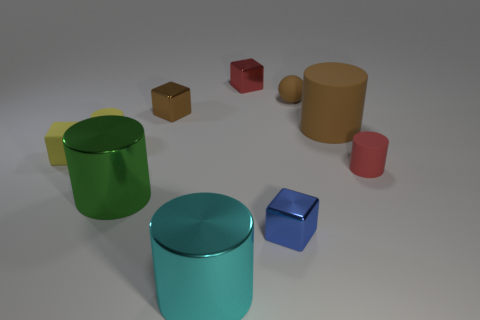What material is the large object that is the same color as the ball?
Your response must be concise. Rubber. There is a tiny yellow object that is the same shape as the big brown matte object; what material is it?
Your answer should be very brief. Rubber. What number of cylinders have the same size as the green thing?
Ensure brevity in your answer.  2. What is the color of the tiny ball that is the same material as the yellow block?
Offer a very short reply. Brown. Are there fewer tiny objects than tiny purple cylinders?
Your answer should be very brief. No. What number of cyan things are either small rubber balls or big rubber cylinders?
Offer a very short reply. 0. How many rubber objects are both on the right side of the ball and to the left of the red rubber thing?
Provide a short and direct response. 1. Are the brown ball and the big cyan cylinder made of the same material?
Offer a terse response. No. What is the shape of the red matte thing that is the same size as the red metallic block?
Provide a short and direct response. Cylinder. Are there more small brown metal blocks than big purple cubes?
Provide a succinct answer. Yes. 